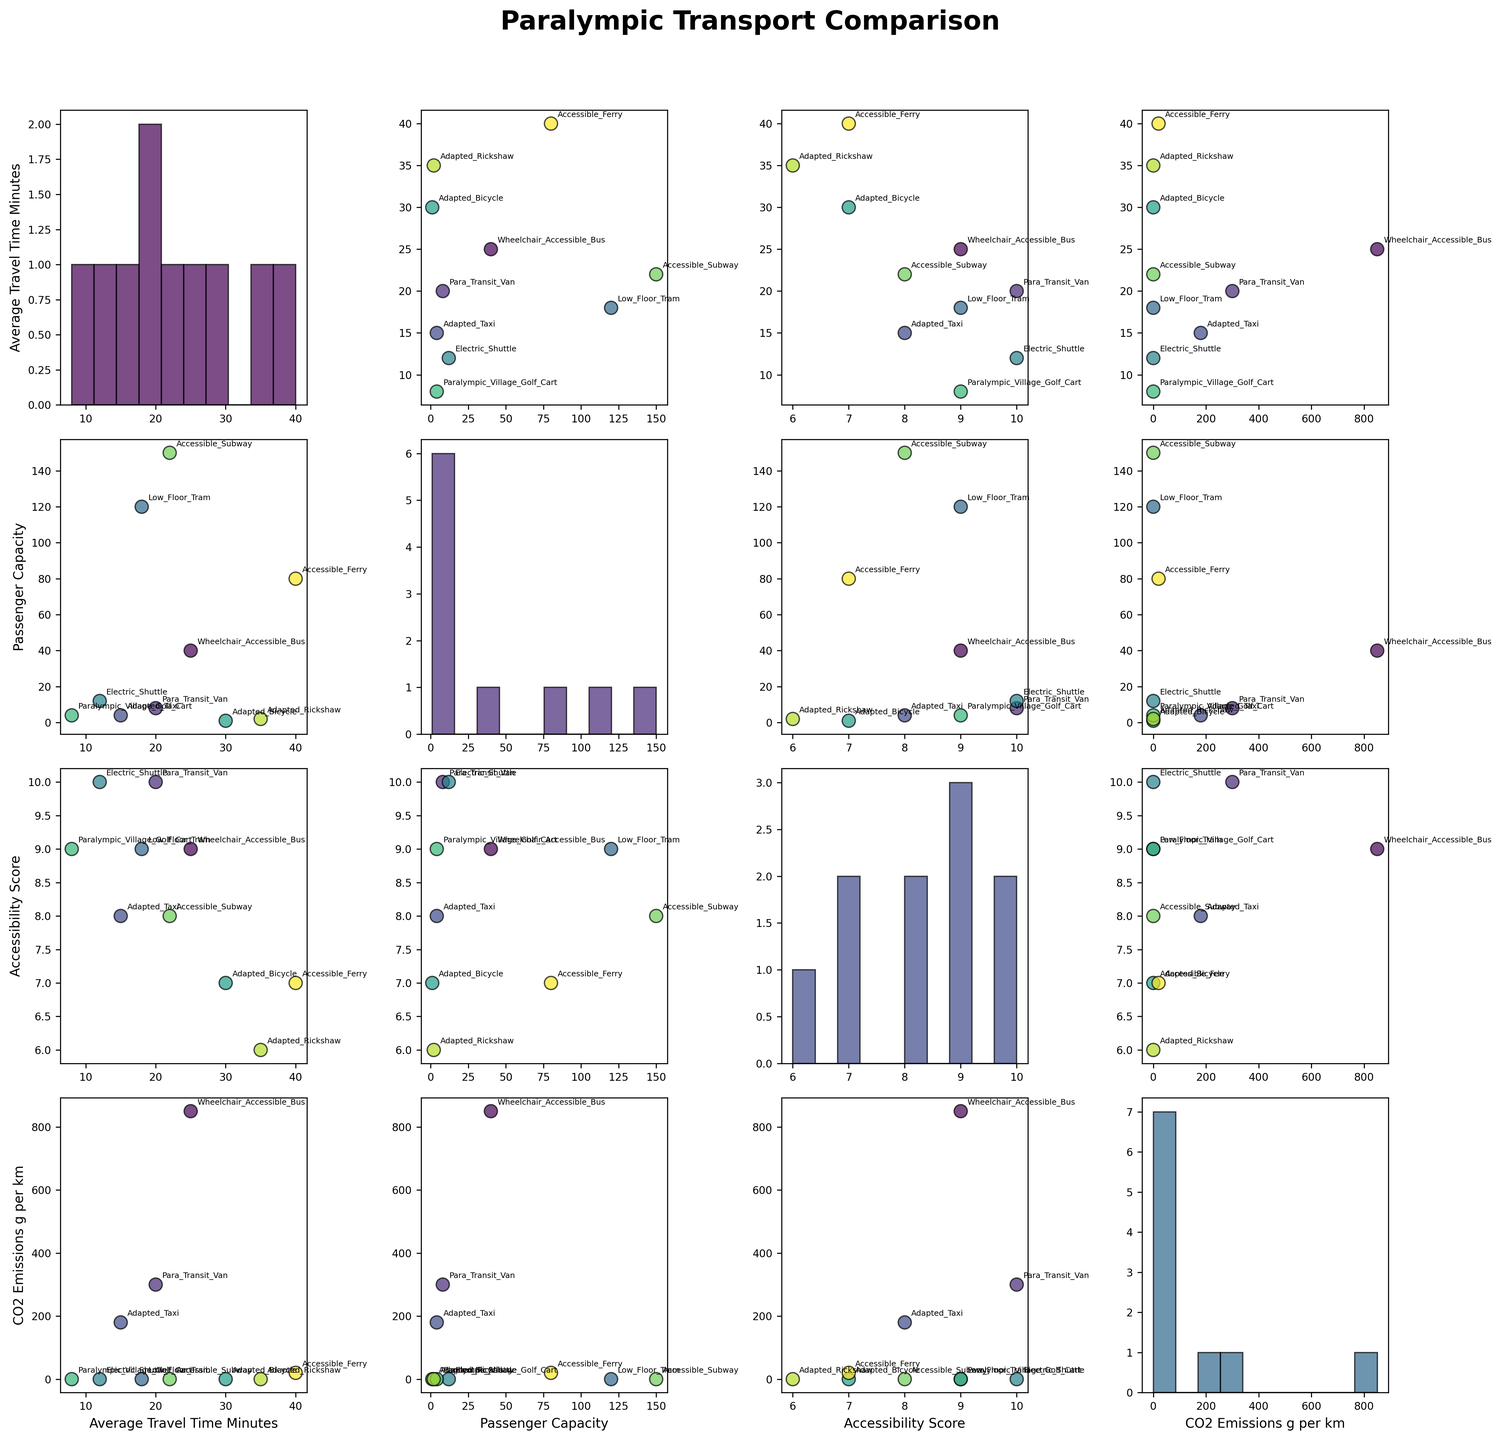What is the title of the scatterplot matrix? The title of the scatterplot matrix is typically displayed at the top of the figure. Look at the top of the figure to find the text indicating the title.
Answer: Paralympic Transport Comparison How many transport modes are displayed in the figure? Count the unique labels or annotations for each data point in any scatter plot within the matrix. Every point should have a label corresponding to one of the transport modes.
Answer: 10 Which transport mode has the highest passenger capacity? In the column corresponding to "Passenger Capacity," find the scatter plot with "Passenger Capacity" on the y-axis and identify the transport mode with the highest data point.
Answer: Accessible Subway Which transport mode has the lowest average travel time? In the scatter plot where "Average Travel Time Minutes" is on the y-axis, find the transport mode corresponding to the lowest data point in that plot.
Answer: Paralympic Village Golf Cart What is the relationship between CO2 emissions and passenger capacity for wheelchair-accessible bus? Locate the scatter plot where "CO2 Emissions g per km" is on one axis and "Passenger Capacity" on the other. Identify the point labeled for the wheelchair-accessible bus and observe its position in relation to the two axes.
Answer: High CO2 emissions, moderate capacity On which diagonal histogram is the average travel time represented? Look at the diagonal of the scatterplot matrix and identify which of the histograms represents the "Average Travel Time Minutes" variable. The diagonal histograms represent the same variable on both axes.
Answer: Top-left Which transport mode has the highest accessibility score, and does it have low or high emissions? Find the maximum point in the scatter plot with "Accessibility Score" on the y-axis and check its location in the scatter plot where "CO2 Emissions g per km" is on the y-axis.
Answer: Para Transit Van, low emissions What is the range of average travel times across all transport modes? Identify the vertical span of points in any scatter plot with "Average Travel Time Minutes" on the y-axis. The minimum and maximum values will give the range.
Answer: 8 to 40 minutes Which transport mode provides a balance between high passenger capacity and zero CO2 emissions? Locate the scatter plot for "Passenger Capacity" vs. "CO2 Emissions g per km" and identify the transport modes at zero CO2 emissions with relatively high passenger capacities.
Answer: Low Floor Tram How does the adapted taxi compare to the electric shuttle in terms of accessibility score and average travel time? Compare the positions of both transport modes in the scatter plots where "Accessibility Score" is on one axis and where "Average Travel Time Minutes" is on one axis.
Answer: Adapted Taxi has lower accessibility, higher travel time 